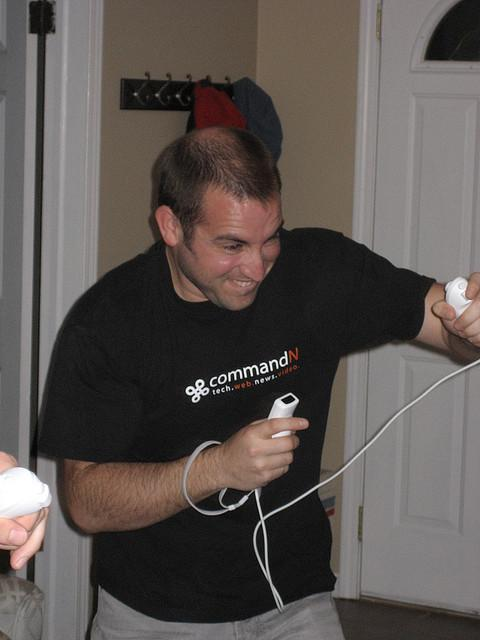What is wrapped around his wrist?

Choices:
A) yarn
B) string
C) cord
D) ribbon cord 